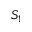Convert formula to latex. <formula><loc_0><loc_0><loc_500><loc_500>S _ { 1 }</formula> 